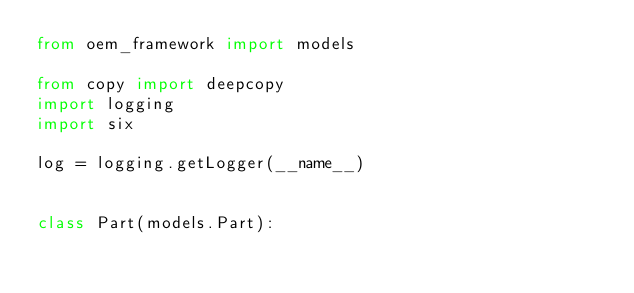<code> <loc_0><loc_0><loc_500><loc_500><_Python_>from oem_framework import models

from copy import deepcopy
import logging
import six

log = logging.getLogger(__name__)


class Part(models.Part):</code> 